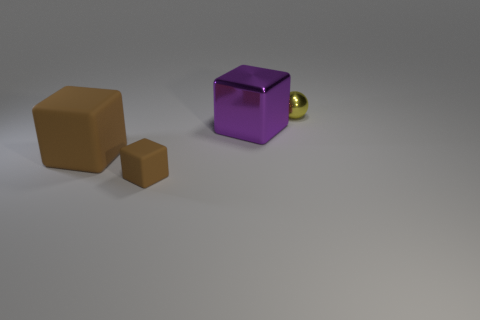What size is the other block that is the same color as the big matte cube?
Your answer should be compact. Small. Is the color of the object that is to the left of the tiny block the same as the tiny object that is in front of the big purple shiny thing?
Your answer should be compact. Yes. What is the shape of the small matte object that is the same color as the large rubber object?
Offer a terse response. Cube. The large object right of the brown object in front of the rubber block that is behind the small cube is what color?
Your response must be concise. Purple. The small object that is the same shape as the big brown thing is what color?
Provide a short and direct response. Brown. Is there anything else that is the same color as the small cube?
Provide a succinct answer. Yes. What number of other things are there of the same material as the small block
Ensure brevity in your answer.  1. The purple block has what size?
Keep it short and to the point. Large. Is there a large brown rubber object that has the same shape as the small matte object?
Offer a terse response. Yes. What number of objects are small red rubber balls or large things to the left of the large purple block?
Keep it short and to the point. 1. 